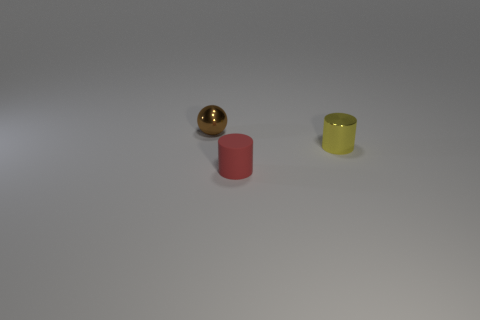Is the object in front of the tiny metal cylinder made of the same material as the sphere?
Ensure brevity in your answer.  No. The brown thing has what size?
Your answer should be compact. Small. How many cubes are either yellow metal things or shiny things?
Make the answer very short. 0. Are there the same number of spheres that are behind the brown sphere and metallic balls in front of the red cylinder?
Offer a terse response. Yes. What size is the other yellow object that is the same shape as the rubber object?
Provide a succinct answer. Small. There is a object that is both behind the rubber cylinder and in front of the shiny sphere; how big is it?
Your response must be concise. Small. There is a small metallic cylinder; are there any tiny brown metal things in front of it?
Give a very brief answer. No. How many objects are either small red cylinders in front of the small sphere or tiny red cylinders?
Offer a very short reply. 1. There is a metallic thing that is right of the brown thing; how many tiny cylinders are in front of it?
Your answer should be very brief. 1. Are there fewer small red cylinders on the left side of the tiny red cylinder than brown objects right of the brown metal object?
Your answer should be very brief. No. 